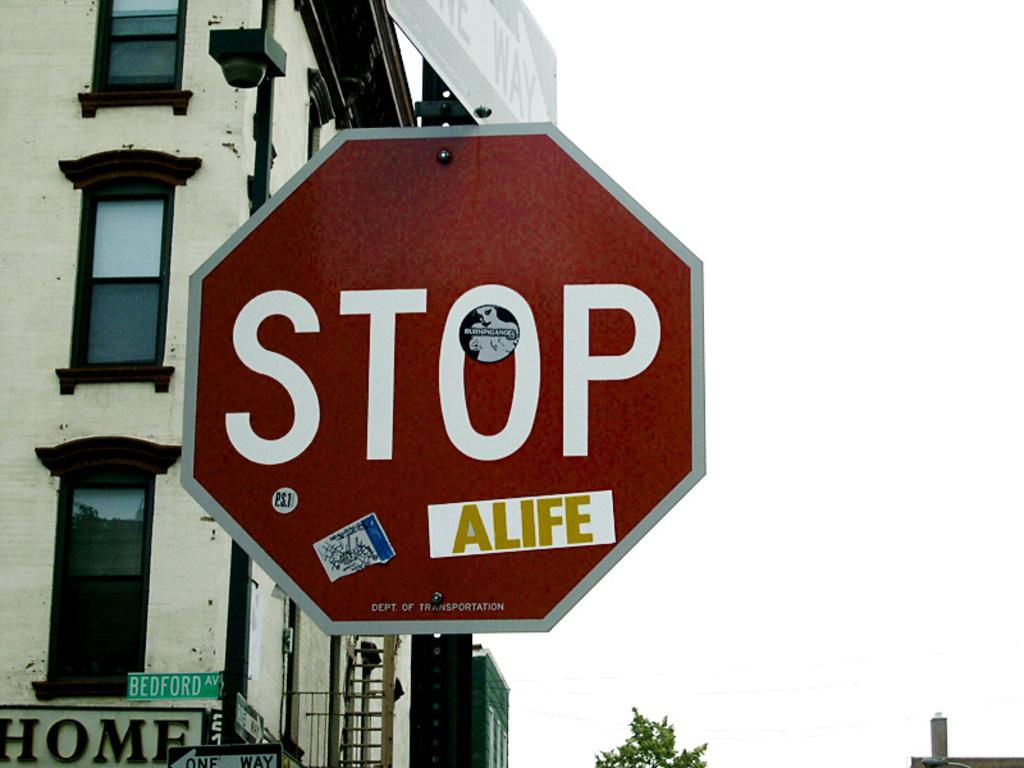<image>
Render a clear and concise summary of the photo. A sticker attached to a road sign amends the message to read Stop A Life. 